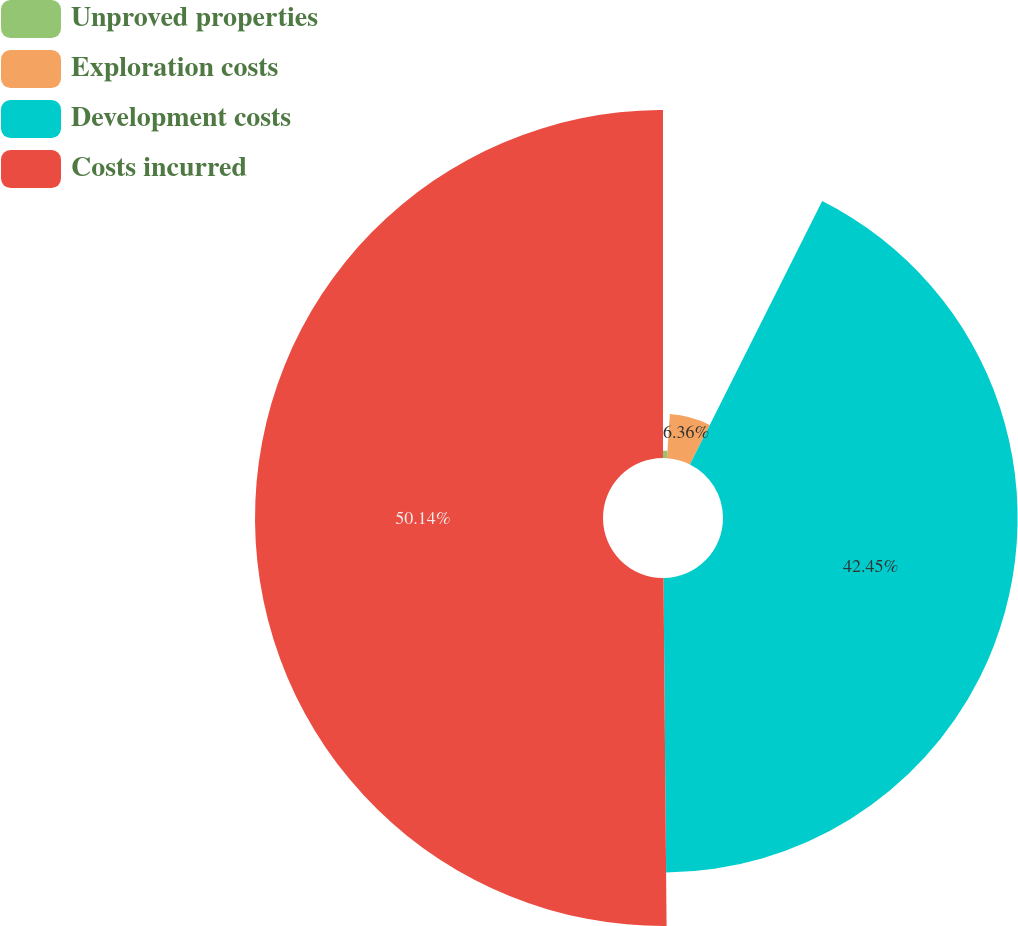<chart> <loc_0><loc_0><loc_500><loc_500><pie_chart><fcel>Unproved properties<fcel>Exploration costs<fcel>Development costs<fcel>Costs incurred<nl><fcel>1.05%<fcel>6.36%<fcel>42.45%<fcel>50.14%<nl></chart> 